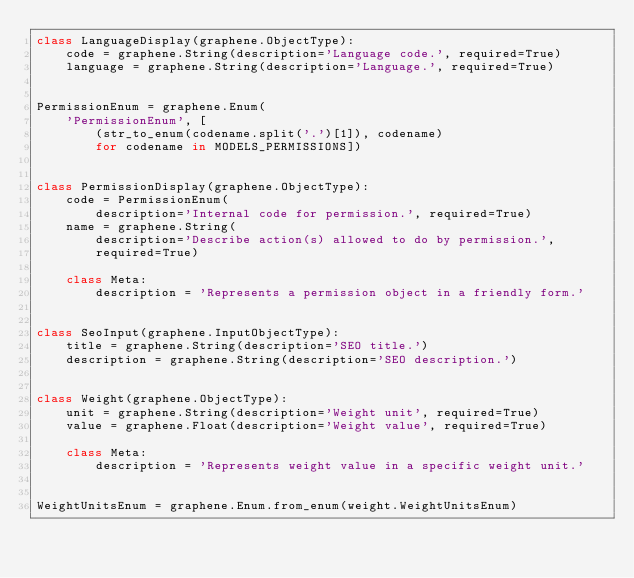<code> <loc_0><loc_0><loc_500><loc_500><_Python_>class LanguageDisplay(graphene.ObjectType):
    code = graphene.String(description='Language code.', required=True)
    language = graphene.String(description='Language.', required=True)


PermissionEnum = graphene.Enum(
    'PermissionEnum', [
        (str_to_enum(codename.split('.')[1]), codename)
        for codename in MODELS_PERMISSIONS])


class PermissionDisplay(graphene.ObjectType):
    code = PermissionEnum(
        description='Internal code for permission.', required=True)
    name = graphene.String(
        description='Describe action(s) allowed to do by permission.',
        required=True)

    class Meta:
        description = 'Represents a permission object in a friendly form.'


class SeoInput(graphene.InputObjectType):
    title = graphene.String(description='SEO title.')
    description = graphene.String(description='SEO description.')


class Weight(graphene.ObjectType):
    unit = graphene.String(description='Weight unit', required=True)
    value = graphene.Float(description='Weight value', required=True)

    class Meta:
        description = 'Represents weight value in a specific weight unit.'


WeightUnitsEnum = graphene.Enum.from_enum(weight.WeightUnitsEnum)
</code> 